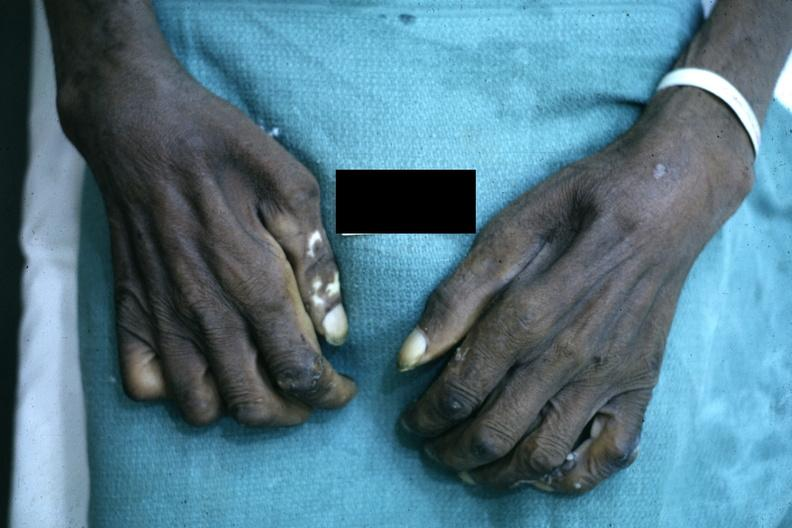how is close-up excellent example of interosseous muscle atrophy said to be to syringomyelus?
Answer the question using a single word or phrase. Due 